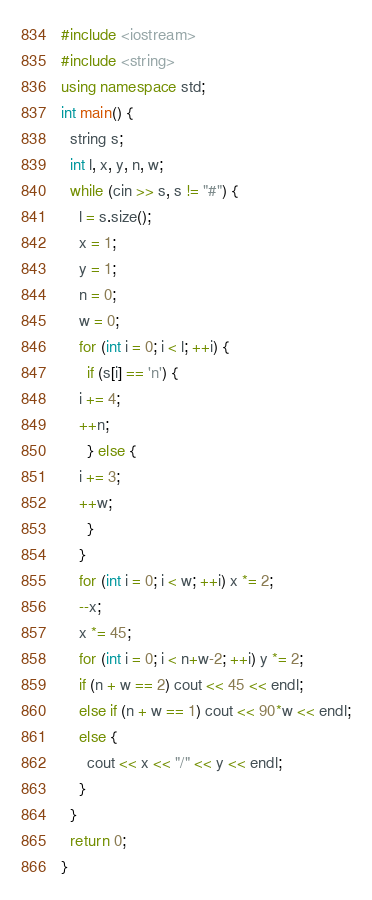Convert code to text. <code><loc_0><loc_0><loc_500><loc_500><_C++_>#include <iostream>
#include <string>
using namespace std;
int main() {
  string s;
  int l, x, y, n, w;
  while (cin >> s, s != "#") {
    l = s.size();
    x = 1;
    y = 1;
    n = 0;
    w = 0;
    for (int i = 0; i < l; ++i) {
      if (s[i] == 'n') {
	i += 4;
	++n;
      } else {
	i += 3;
	++w;
      }
    }
    for (int i = 0; i < w; ++i) x *= 2;
    --x;
    x *= 45;
    for (int i = 0; i < n+w-2; ++i) y *= 2;
    if (n + w == 2) cout << 45 << endl;
    else if (n + w == 1) cout << 90*w << endl;
    else {
      cout << x << "/" << y << endl;
    }
  }
  return 0;
}</code> 